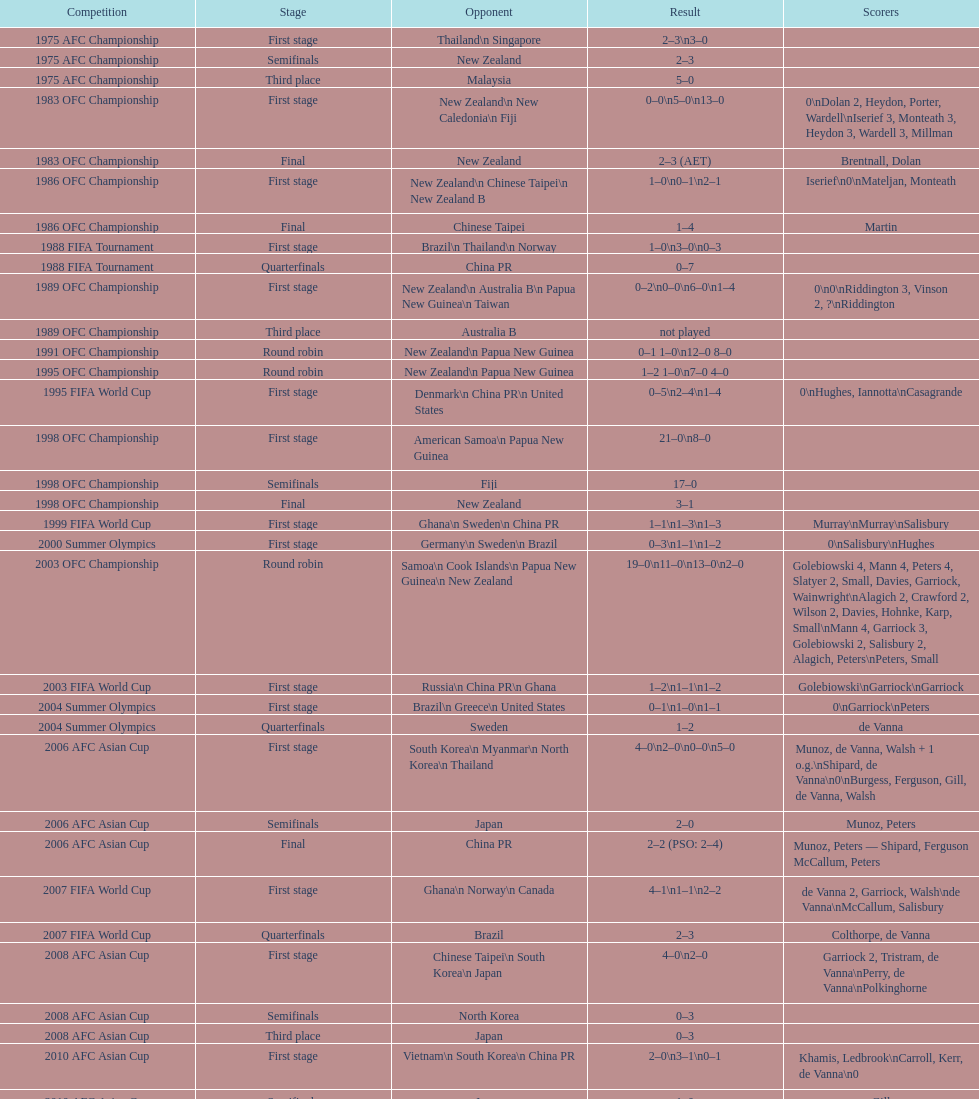Who was the last rival this team played against in the 2010 afc asian cup? North Korea. Would you mind parsing the complete table? {'header': ['Competition', 'Stage', 'Opponent', 'Result', 'Scorers'], 'rows': [['1975 AFC Championship', 'First stage', 'Thailand\\n\xa0Singapore', '2–3\\n3–0', ''], ['1975 AFC Championship', 'Semifinals', 'New Zealand', '2–3', ''], ['1975 AFC Championship', 'Third place', 'Malaysia', '5–0', ''], ['1983 OFC Championship', 'First stage', 'New Zealand\\n\xa0New Caledonia\\n\xa0Fiji', '0–0\\n5–0\\n13–0', '0\\nDolan 2, Heydon, Porter, Wardell\\nIserief 3, Monteath 3, Heydon 3, Wardell 3, Millman'], ['1983 OFC Championship', 'Final', 'New Zealand', '2–3 (AET)', 'Brentnall, Dolan'], ['1986 OFC Championship', 'First stage', 'New Zealand\\n\xa0Chinese Taipei\\n New Zealand B', '1–0\\n0–1\\n2–1', 'Iserief\\n0\\nMateljan, Monteath'], ['1986 OFC Championship', 'Final', 'Chinese Taipei', '1–4', 'Martin'], ['1988 FIFA Tournament', 'First stage', 'Brazil\\n\xa0Thailand\\n\xa0Norway', '1–0\\n3–0\\n0–3', ''], ['1988 FIFA Tournament', 'Quarterfinals', 'China PR', '0–7', ''], ['1989 OFC Championship', 'First stage', 'New Zealand\\n Australia B\\n\xa0Papua New Guinea\\n\xa0Taiwan', '0–2\\n0–0\\n6–0\\n1–4', '0\\n0\\nRiddington 3, Vinson 2,\xa0?\\nRiddington'], ['1989 OFC Championship', 'Third place', 'Australia B', 'not played', ''], ['1991 OFC Championship', 'Round robin', 'New Zealand\\n\xa0Papua New Guinea', '0–1 1–0\\n12–0 8–0', ''], ['1995 OFC Championship', 'Round robin', 'New Zealand\\n\xa0Papua New Guinea', '1–2 1–0\\n7–0 4–0', ''], ['1995 FIFA World Cup', 'First stage', 'Denmark\\n\xa0China PR\\n\xa0United States', '0–5\\n2–4\\n1–4', '0\\nHughes, Iannotta\\nCasagrande'], ['1998 OFC Championship', 'First stage', 'American Samoa\\n\xa0Papua New Guinea', '21–0\\n8–0', ''], ['1998 OFC Championship', 'Semifinals', 'Fiji', '17–0', ''], ['1998 OFC Championship', 'Final', 'New Zealand', '3–1', ''], ['1999 FIFA World Cup', 'First stage', 'Ghana\\n\xa0Sweden\\n\xa0China PR', '1–1\\n1–3\\n1–3', 'Murray\\nMurray\\nSalisbury'], ['2000 Summer Olympics', 'First stage', 'Germany\\n\xa0Sweden\\n\xa0Brazil', '0–3\\n1–1\\n1–2', '0\\nSalisbury\\nHughes'], ['2003 OFC Championship', 'Round robin', 'Samoa\\n\xa0Cook Islands\\n\xa0Papua New Guinea\\n\xa0New Zealand', '19–0\\n11–0\\n13–0\\n2–0', 'Golebiowski 4, Mann 4, Peters 4, Slatyer 2, Small, Davies, Garriock, Wainwright\\nAlagich 2, Crawford 2, Wilson 2, Davies, Hohnke, Karp, Small\\nMann 4, Garriock 3, Golebiowski 2, Salisbury 2, Alagich, Peters\\nPeters, Small'], ['2003 FIFA World Cup', 'First stage', 'Russia\\n\xa0China PR\\n\xa0Ghana', '1–2\\n1–1\\n1–2', 'Golebiowski\\nGarriock\\nGarriock'], ['2004 Summer Olympics', 'First stage', 'Brazil\\n\xa0Greece\\n\xa0United States', '0–1\\n1–0\\n1–1', '0\\nGarriock\\nPeters'], ['2004 Summer Olympics', 'Quarterfinals', 'Sweden', '1–2', 'de Vanna'], ['2006 AFC Asian Cup', 'First stage', 'South Korea\\n\xa0Myanmar\\n\xa0North Korea\\n\xa0Thailand', '4–0\\n2–0\\n0–0\\n5–0', 'Munoz, de Vanna, Walsh + 1 o.g.\\nShipard, de Vanna\\n0\\nBurgess, Ferguson, Gill, de Vanna, Walsh'], ['2006 AFC Asian Cup', 'Semifinals', 'Japan', '2–0', 'Munoz, Peters'], ['2006 AFC Asian Cup', 'Final', 'China PR', '2–2 (PSO: 2–4)', 'Munoz, Peters — Shipard, Ferguson McCallum, Peters'], ['2007 FIFA World Cup', 'First stage', 'Ghana\\n\xa0Norway\\n\xa0Canada', '4–1\\n1–1\\n2–2', 'de Vanna 2, Garriock, Walsh\\nde Vanna\\nMcCallum, Salisbury'], ['2007 FIFA World Cup', 'Quarterfinals', 'Brazil', '2–3', 'Colthorpe, de Vanna'], ['2008 AFC Asian Cup', 'First stage', 'Chinese Taipei\\n\xa0South Korea\\n\xa0Japan', '4–0\\n2–0', 'Garriock 2, Tristram, de Vanna\\nPerry, de Vanna\\nPolkinghorne'], ['2008 AFC Asian Cup', 'Semifinals', 'North Korea', '0–3', ''], ['2008 AFC Asian Cup', 'Third place', 'Japan', '0–3', ''], ['2010 AFC Asian Cup', 'First stage', 'Vietnam\\n\xa0South Korea\\n\xa0China PR', '2–0\\n3–1\\n0–1', 'Khamis, Ledbrook\\nCarroll, Kerr, de Vanna\\n0'], ['2010 AFC Asian Cup', 'Semifinals', 'Japan', '1–0', 'Gill'], ['2010 AFC Asian Cup', 'Final', 'North Korea', '1–1 (PSO: 5–4)', 'Kerr — PSO: Shipard, Ledbrook, Gill, Garriock, Simon'], ['2011 FIFA World Cup', 'First stage', 'Brazil\\n\xa0Equatorial Guinea\\n\xa0Norway', '0–1\\n3–2\\n2–1', '0\\nvan Egmond, Khamis, de Vanna\\nSimon 2'], ['2011 FIFA World Cup', 'Quarterfinals', 'Sweden', '1–3', 'Perry'], ['2012 Summer Olympics\\nAFC qualification', 'Final round', 'North Korea\\n\xa0Thailand\\n\xa0Japan\\n\xa0China PR\\n\xa0South Korea', '0–1\\n5–1\\n0–1\\n1–0\\n2–1', '0\\nHeyman 2, Butt, van Egmond, Simon\\n0\\nvan Egmond\\nButt, de Vanna'], ['2014 AFC Asian Cup', 'First stage', 'Japan\\n\xa0Jordan\\n\xa0Vietnam', 'TBD\\nTBD\\nTBD', '']]} 